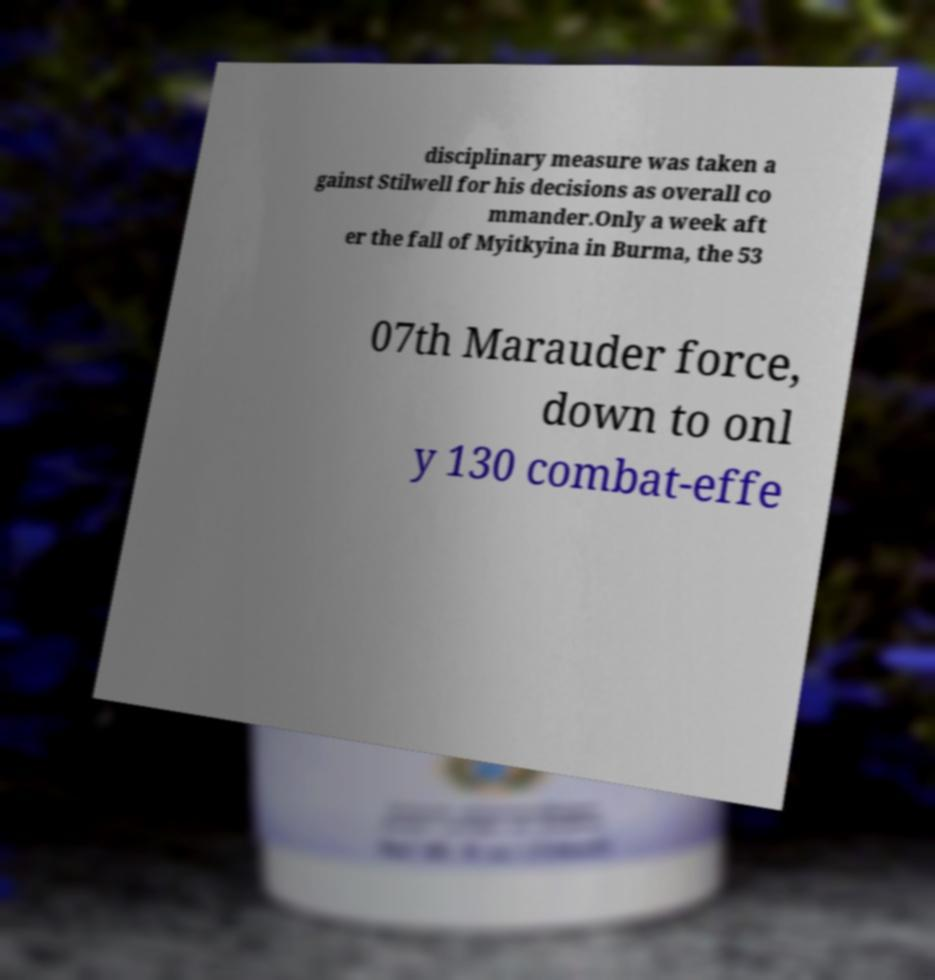Can you read and provide the text displayed in the image?This photo seems to have some interesting text. Can you extract and type it out for me? disciplinary measure was taken a gainst Stilwell for his decisions as overall co mmander.Only a week aft er the fall of Myitkyina in Burma, the 53 07th Marauder force, down to onl y 130 combat-effe 